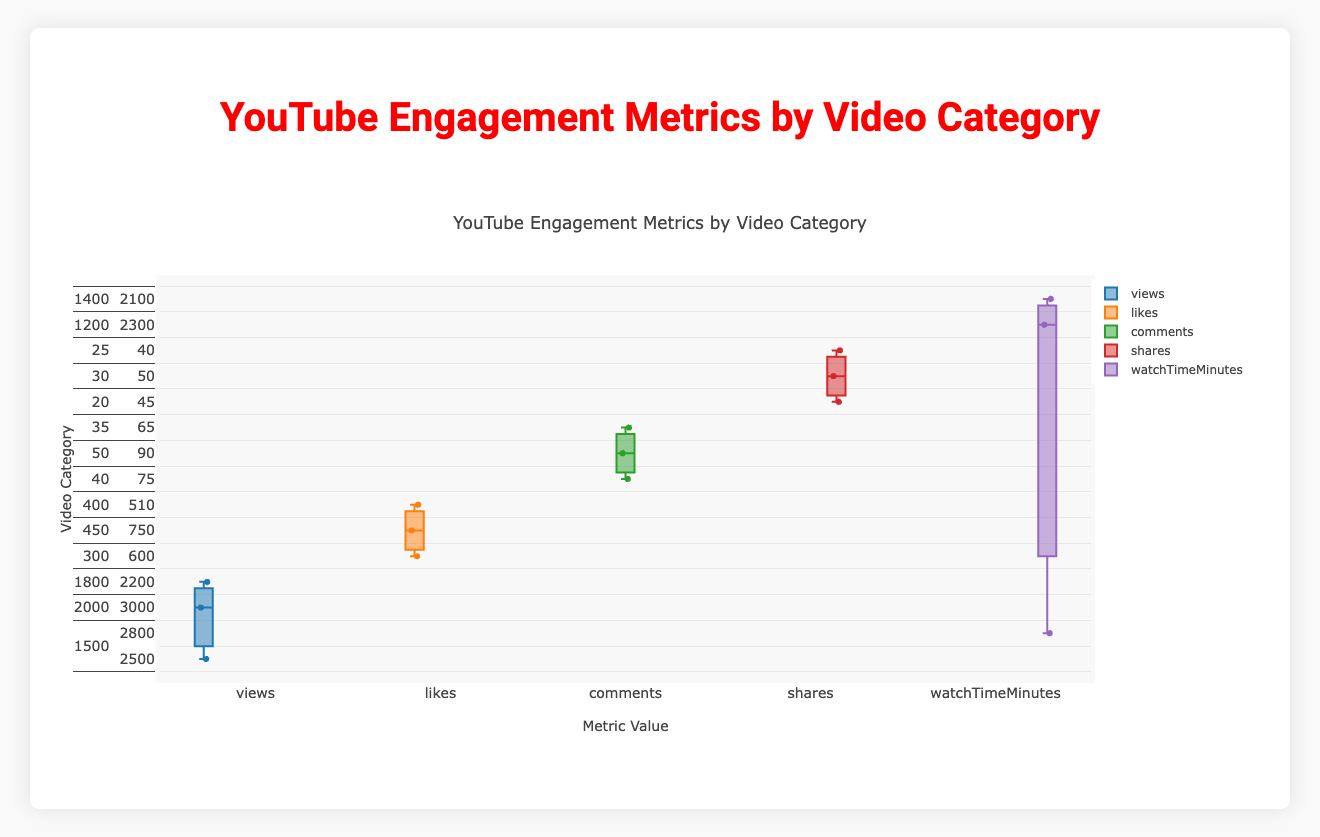What is the title of the plot? The title of the plot can be found at the top of the figure. In this case, it is stated clearly.
Answer: YouTube Engagement Metrics by Video Category What are the categories displayed on the y-axis? The y-axis lists each video category. By observing the plot, you can see these categories.
Answer: Vlogs, Tutorials, Reviews, Entertainment, Education Which category has the highest median likes? To determine which category has the highest median likes, look at the median line within each box plot of the 'likes' metric.
Answer: Entertainment What is the interquartile range (IQR) for the watch time in the Reviews category? To find the IQR for a category, locate the box plot for the 'Reviews' under the 'watchTimeMinutes' metric. The IQR is the difference between the top and bottom of the box (the third quartile minus the first quartile).
Answer: 1500 Which category shows the widest range for comments? The range is the difference between the highest and lowest values (the endpoints of the whiskers). Compare the ranges across all categories for the 'comments' metric.
Answer: Entertainment Are there any outliers in the views metric for the Tutorials category? Outliers in a box plot are typically represented as individual points outside the whiskers. Check the box plot for 'views' under 'Tutorials' to identify if there are any such points.
Answer: No What is the median value of the views for the Vlogs category? The median is represented by the line inside the box of the Vlogs category for the 'views' metric. Refer to this line to find the median value.
Answer: 1800 Which category has the lowest minimum value for shares? The minimum value is indicated by the lower whisker or the lowest point. Compare the lowest values across categories for the 'shares' metric.
Answer: Education How does the median watch time for Education compare to that of Tutorials? Compare the median lines of both the Education and Tutorials box plots under the 'watchTimeMinutes' metric.
Answer: The median watch time for Education is lower than that of Tutorials What is the difference between the maximum likes for Reviews and Tutorials? The maximum value is represented by the top whisker or the highest point of the box plot. Find the highest likes value for both Reviews and Tutorials and calculate the difference.
Answer: 450 